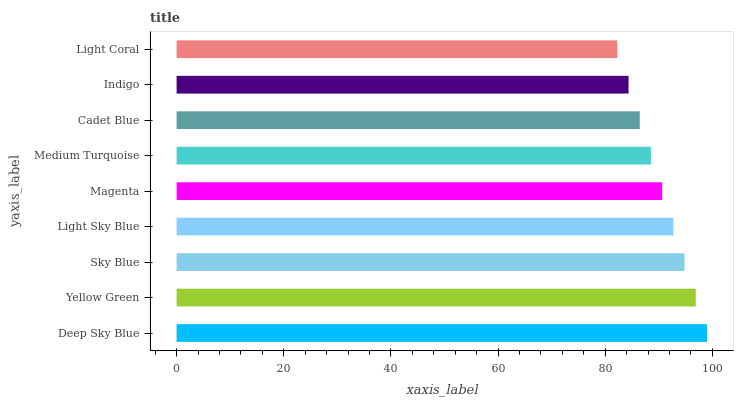Is Light Coral the minimum?
Answer yes or no. Yes. Is Deep Sky Blue the maximum?
Answer yes or no. Yes. Is Yellow Green the minimum?
Answer yes or no. No. Is Yellow Green the maximum?
Answer yes or no. No. Is Deep Sky Blue greater than Yellow Green?
Answer yes or no. Yes. Is Yellow Green less than Deep Sky Blue?
Answer yes or no. Yes. Is Yellow Green greater than Deep Sky Blue?
Answer yes or no. No. Is Deep Sky Blue less than Yellow Green?
Answer yes or no. No. Is Magenta the high median?
Answer yes or no. Yes. Is Magenta the low median?
Answer yes or no. Yes. Is Sky Blue the high median?
Answer yes or no. No. Is Medium Turquoise the low median?
Answer yes or no. No. 